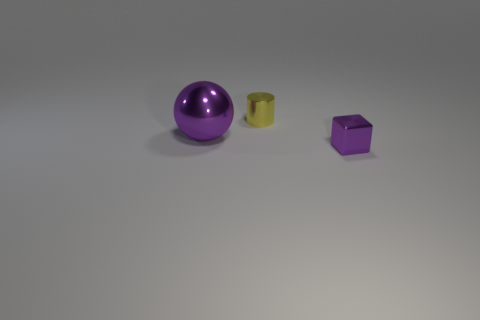Add 3 large brown metallic things. How many objects exist? 6 Subtract all balls. How many objects are left? 2 Add 3 small purple things. How many small purple things are left? 4 Add 2 cylinders. How many cylinders exist? 3 Subtract 0 cyan cylinders. How many objects are left? 3 Subtract all gray spheres. Subtract all red cylinders. How many spheres are left? 1 Subtract all purple blocks. Subtract all small shiny things. How many objects are left? 0 